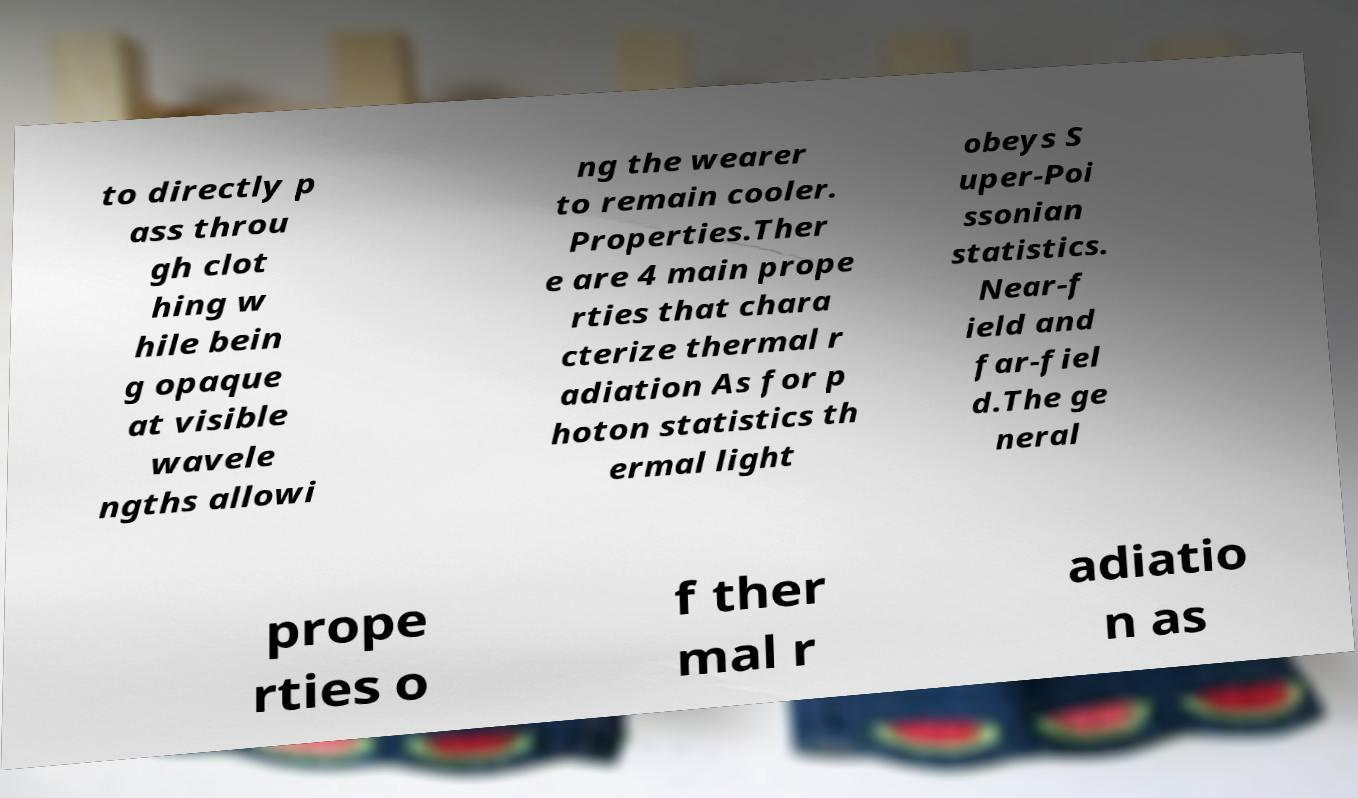Please identify and transcribe the text found in this image. to directly p ass throu gh clot hing w hile bein g opaque at visible wavele ngths allowi ng the wearer to remain cooler. Properties.Ther e are 4 main prope rties that chara cterize thermal r adiation As for p hoton statistics th ermal light obeys S uper-Poi ssonian statistics. Near-f ield and far-fiel d.The ge neral prope rties o f ther mal r adiatio n as 